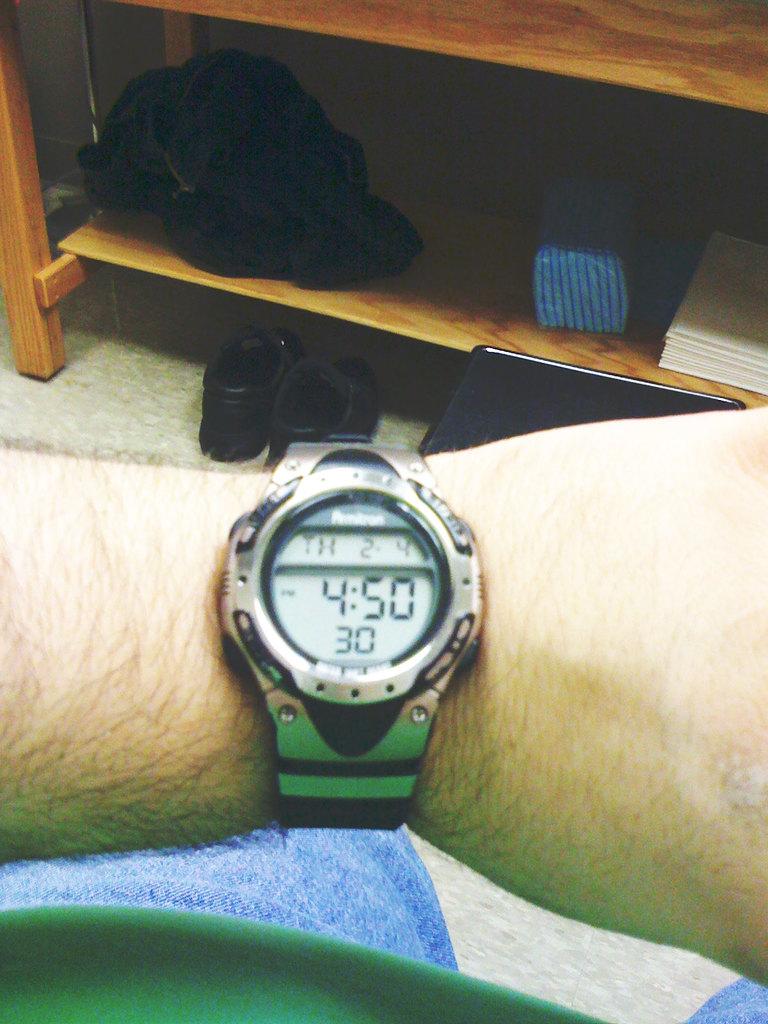What time is it?
Your answer should be compact. 4:50. 